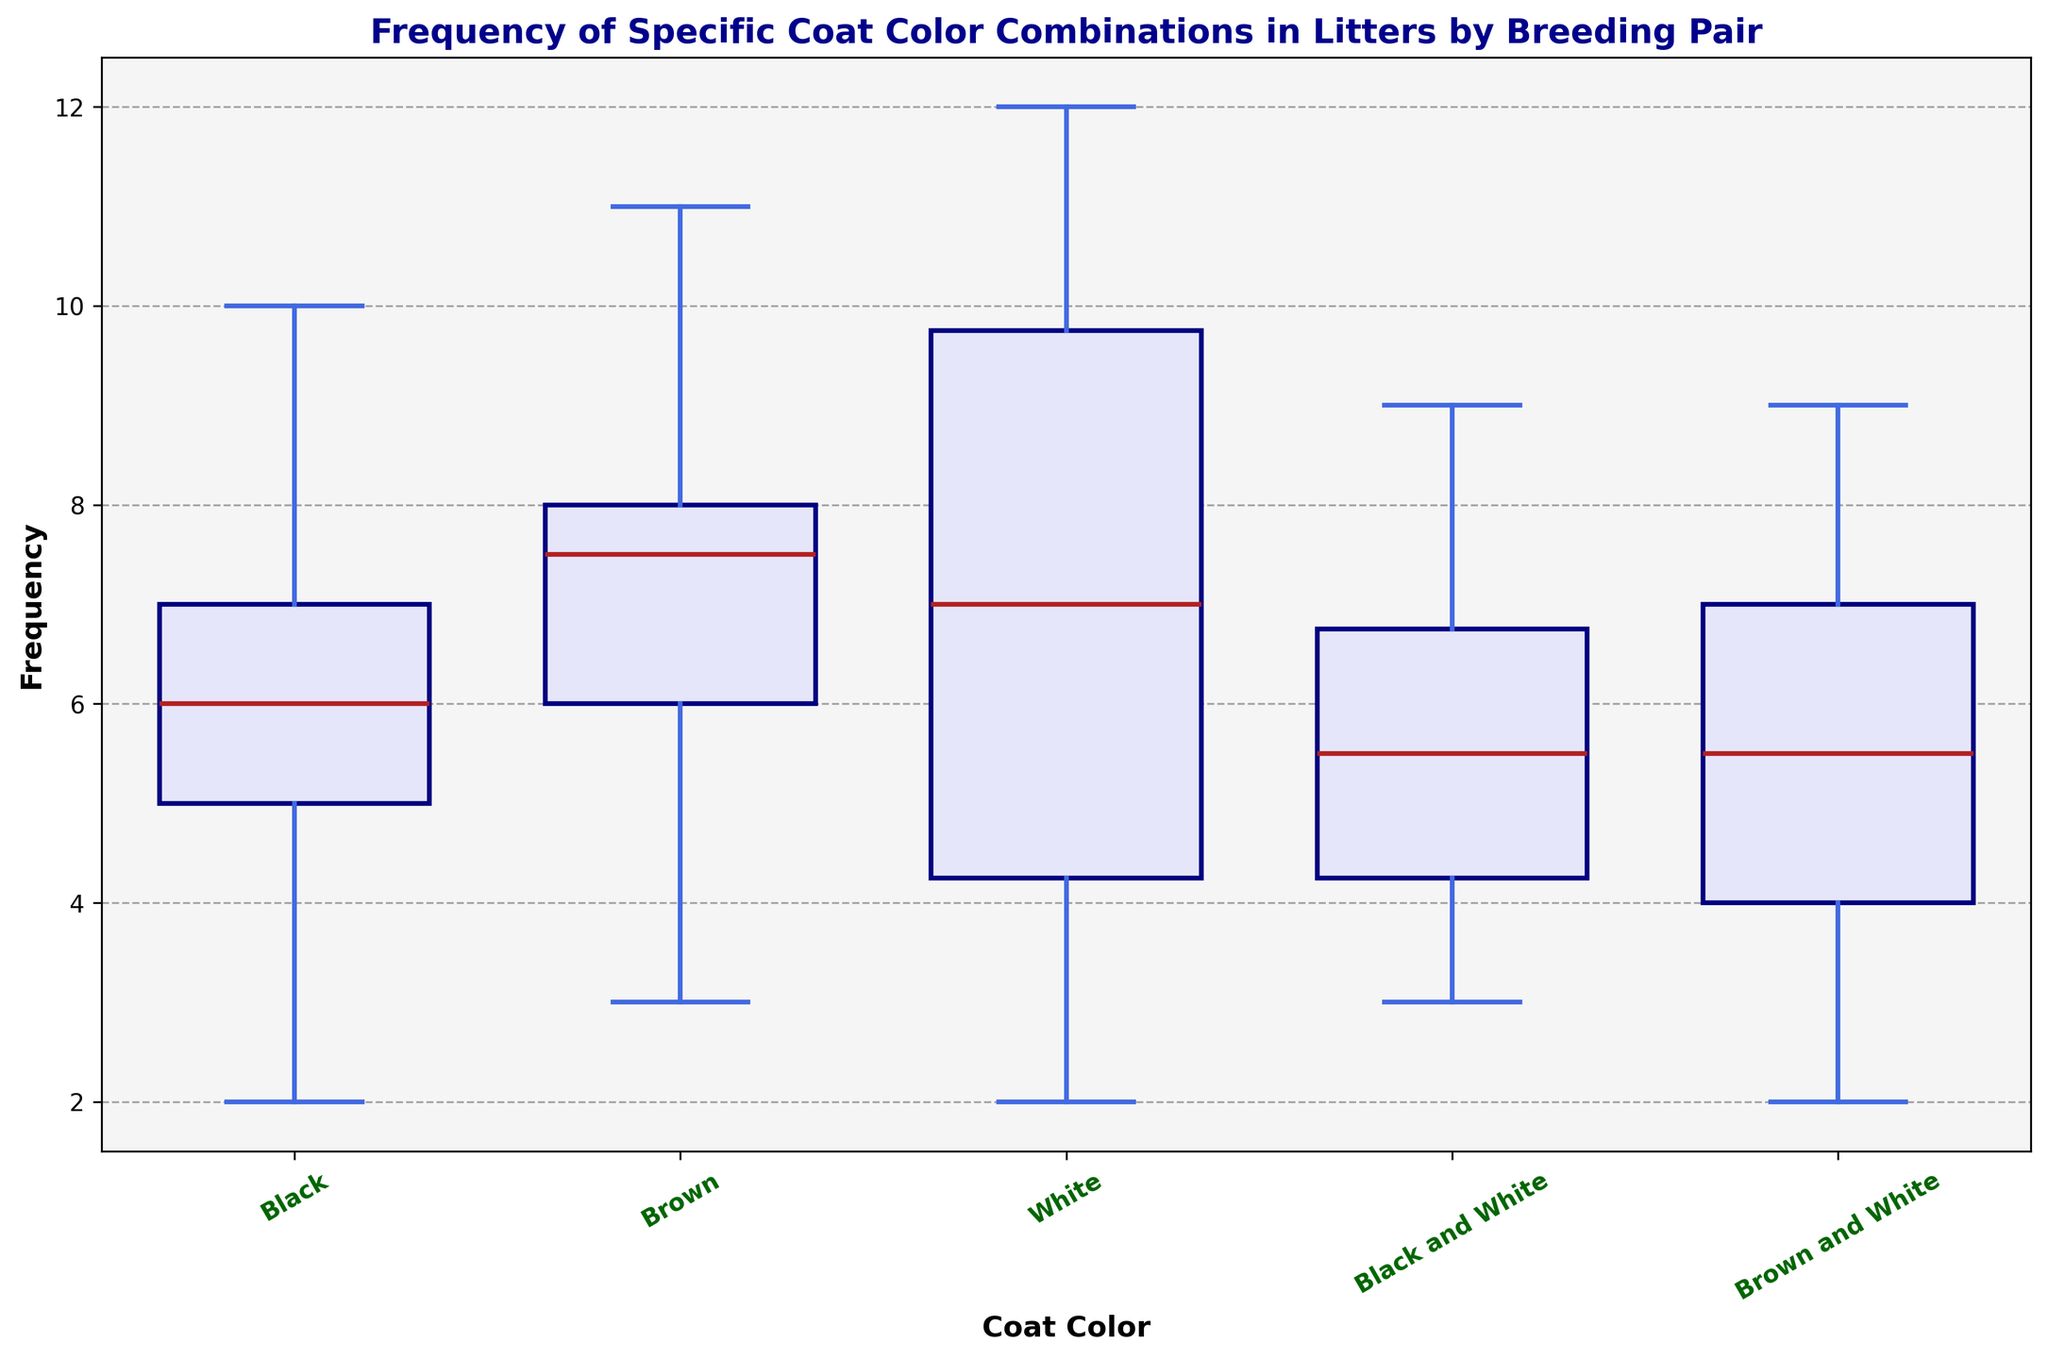Which coat color has the highest median frequency? To identify the coat color with the highest median frequency, look for the box with the highest median line (usually marked by a distinct color like red). The coat color with the line at the highest position has the highest median.
Answer: White Which breeding pair presents the most variability in the "Black and White" coat color? Variability in a box plot is indicated by the interquartile range (IQR), which is the height of the box, and the length of the whiskers. The larger the IQR and the longer the whiskers, the higher the variability. Locate the "Black and White" box that is the tallest and/or has the longest whiskers to identify the breeding pair.
Answer: Pair_4 Is the median frequency of Brown and White greater than that of Black for any breeding pairs? Compare the median lines (horizontal lines inside the boxes) for both "Brown and White" and "Black" coat colors. If the line for "Brown and White" is above the line for "Black" in any breeding pair, the median frequency is higher.
Answer: No What is the range of frequencies for the "Brown" coat color across all breeding pairs? The range is calculated by finding the difference between the maximum and minimum values represented by the whiskers of the "Brown" box. Identify the top whisker (max value) and the bottom whisker (min value) and compute the difference.
Answer: 11 - 3 = 8 Which coat color has the least variation in frequency across all breeding pairs? Variation is indicated by the height of the boxes and the length of the whiskers. The coat color with the smallest box and shortest whiskers has the least variation.
Answer: Black and White Are there any outliers in the "White" coat color frequencies? Outliers in a box plot are often represented by individual points outside the range of the whiskers. Look at the “White” box plot and check if there are any points outside the whiskers.
Answer: Yes What is the mean frequency of the "Black" coat color across all breeding pairs? To calculate the mean frequency, sum up all the frequency values for the "Black" coat color and divide by the number of breeding pairs. The frequencies are 5, 10, 4, 7, 6, 8, 5, 6, 2, 7. Summing them gives 60. There are 10 breeding pairs. So, 60/10 = 6.
Answer: 6 